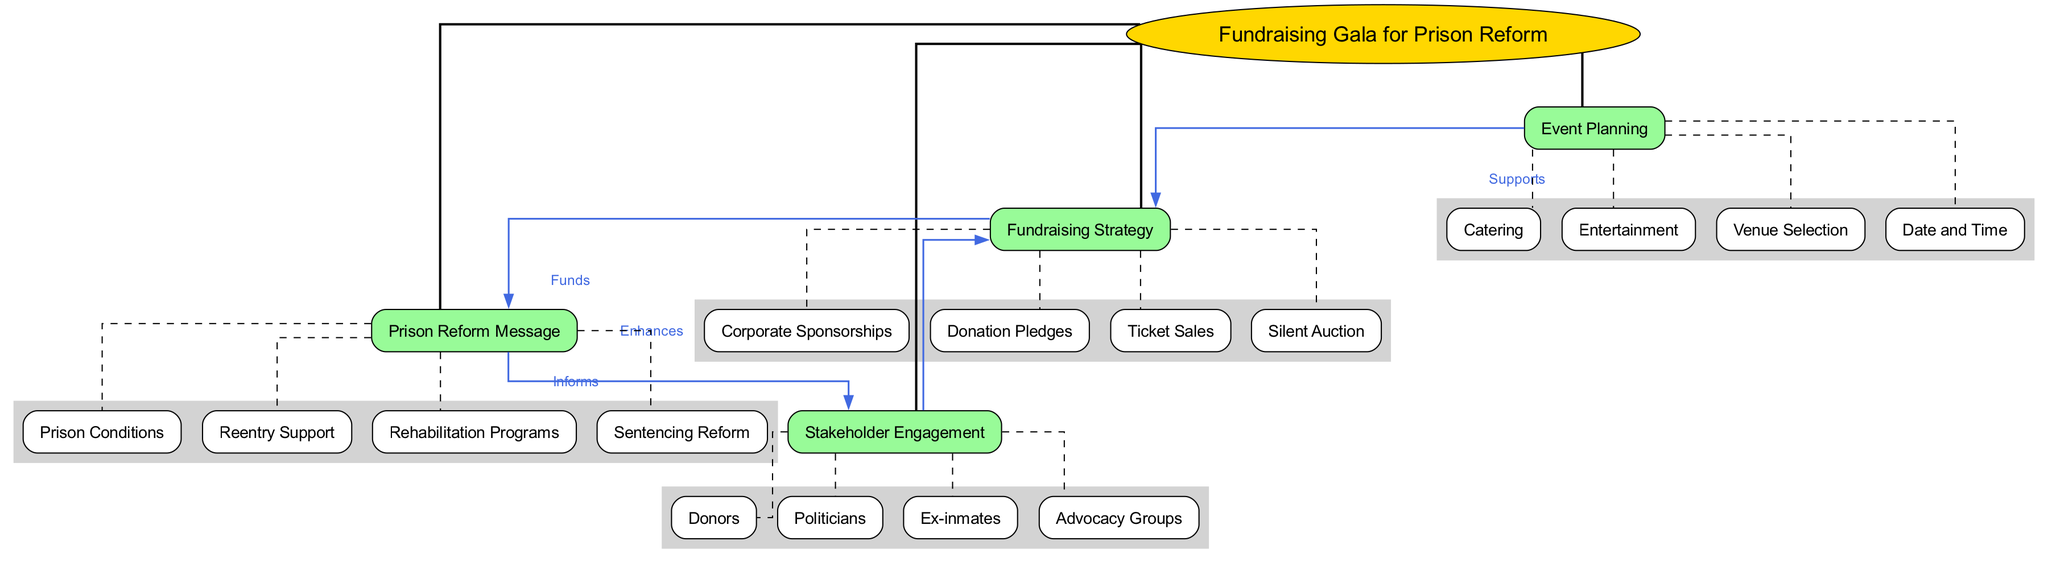What is the central concept of the diagram? The central concept is explicitly stated in the diagram as "Fundraising Gala for Prison Reform." This can be easily identified at the center of the concept map.
Answer: Fundraising Gala for Prison Reform How many main nodes are in the diagram? The diagram lists four main nodes, as shown branching out from the central concept. Counting them gives the total of four.
Answer: 4 What supports the "Fundraising Strategy"? The connection labeled "Supports" shows that "Event Planning" is indicated as supporting the "Fundraising Strategy." The arrow directly points from "Event Planning" to "Fundraising Strategy," making it clear.
Answer: Event Planning Which sub-node is associated with "Stakeholder Engagement"? The sub-nodes under "Stakeholder Engagement" are "Donors," "Politicians," "Ex-inmates," and "Advocacy Groups." You can find these listed underneath the main node.
Answer: Donors How does the "Prison Reform Message" inform "Stakeholder Engagement"? The connection labeled "Informs" indicates that the "Prison Reform Message" provides information relevant to "Stakeholder Engagement." Tracking the arrow from "Prison Reform Message" to "Stakeholder Engagement" illustrates this relationship.
Answer: Informs What enhances the "Fundraising Strategy"? The diagram states that "Stakeholder Engagement" enhances the "Fundraising Strategy." This relationship is depicted with an "Enhances" label on the connecting arrow between the two nodes.
Answer: Stakeholder Engagement How many sub-nodes are associated with "Event Planning"? Under the main node "Event Planning," there are four distinct sub-nodes: "Venue Selection," "Date and Time," "Catering," and "Entertainment." Counting these sub-nodes gives a total of four.
Answer: 4 What is the relationship label between "Fundraising Strategy" and "Prison Reform Message"? The connection from "Fundraising Strategy" to "Prison Reform Message" has the label "Funds." This indicates the role that the fundraising strategy plays concerning the reform message based on the diagram.
Answer: Funds Which sub-node under "Prison Reform Message" relates to improving conditions in correctional facilities? The sub-node "Prison Conditions" directly addresses the aspect of improving conditions in facilities, being one of the listed information points under "Prison Reform Message."
Answer: Prison Conditions 